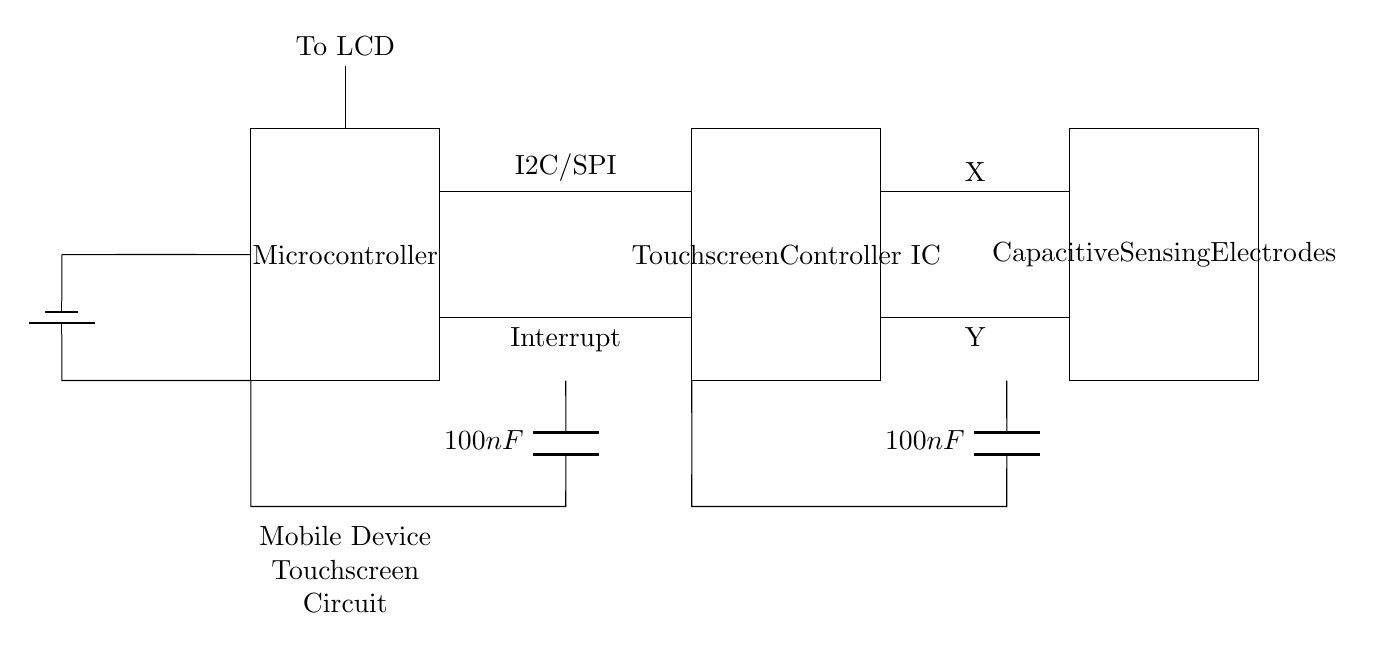What component is responsible for capacitive sensing? The capacitive sensing electrodes are responsible for detecting touch input through capacitance changes.
Answer: Capacitive Sensing Electrodes What communication protocol is used between the microcontroller and the touchscreen controller? The diagram indicates that the communication protocol used is either I2C or SPI, as labeled on the connection line.
Answer: I2C/SPI How many decoupling capacitors are present in the circuit? There are two decoupling capacitors present in the circuit, one connected to the microcontroller and the other connected to the touchscreen controller.
Answer: Two What is the value of the decoupling capacitors? Both decoupling capacitors in the circuit are labeled with a value of one hundred nanofarads.
Answer: One hundred nanofarads What is the function of the interrupt signal in this circuit? The interrupt signal is used to inform the microcontroller of touch events detected by the touchscreen controller, allowing it to respond accordingly.
Answer: Interrupt Which component connects to the LCD? The microcontroller connects to the LCD, as indicated by the line leading from it labeled "To LCD."
Answer: Microcontroller 